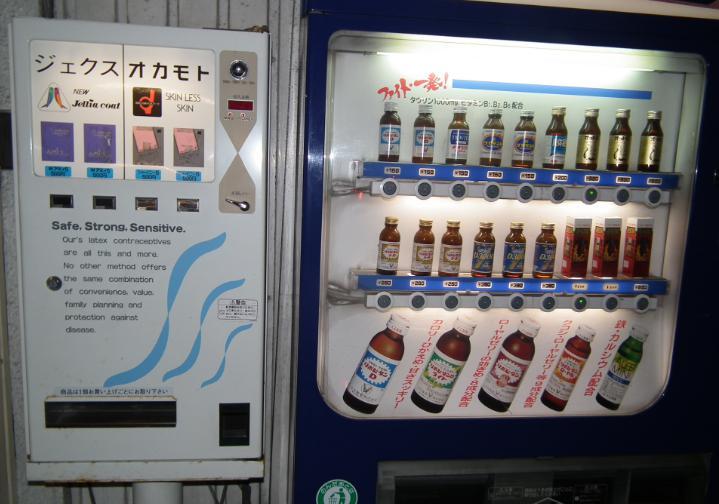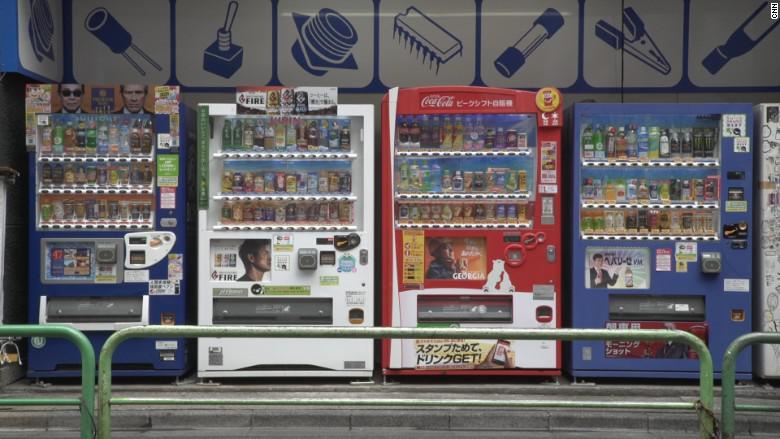The first image is the image on the left, the second image is the image on the right. Analyze the images presented: Is the assertion "Four machines are lined up in the image on the right." valid? Answer yes or no. Yes. The first image is the image on the left, the second image is the image on the right. Considering the images on both sides, is "One image shows blue vending machines flanking two other machines in a row facing the camera head-on." valid? Answer yes or no. Yes. 